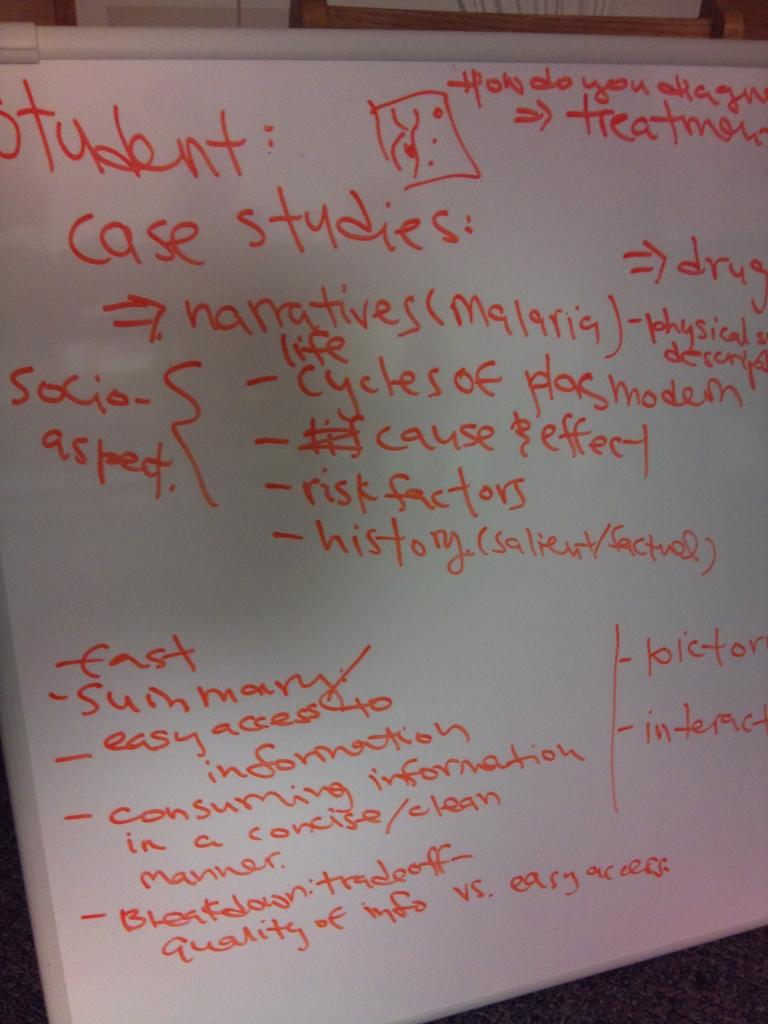Provide a one-sentence caption for the provided image. Orange writing on a whiteboard says student: case studies. 